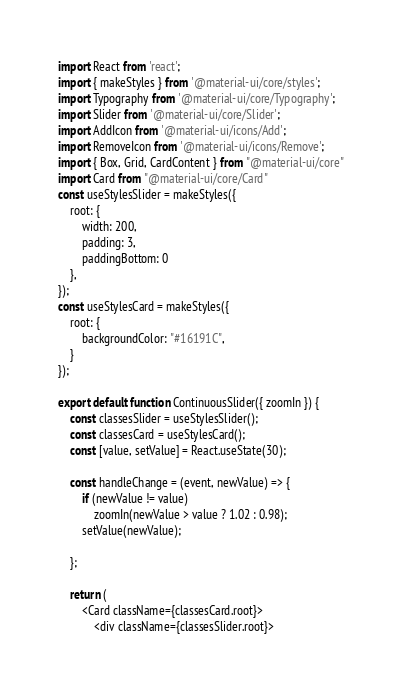<code> <loc_0><loc_0><loc_500><loc_500><_JavaScript_>import React from 'react';
import { makeStyles } from '@material-ui/core/styles';
import Typography from '@material-ui/core/Typography';
import Slider from '@material-ui/core/Slider';
import AddIcon from '@material-ui/icons/Add';
import RemoveIcon from '@material-ui/icons/Remove';
import { Box, Grid, CardContent } from "@material-ui/core"
import Card from "@material-ui/core/Card"
const useStylesSlider = makeStyles({
    root: {
        width: 200,
        padding: 3,
        paddingBottom: 0
    },
});
const useStylesCard = makeStyles({
    root: {
        backgroundColor: "#16191C",
    }
});

export default function ContinuousSlider({ zoomIn }) {
    const classesSlider = useStylesSlider();
    const classesCard = useStylesCard();
    const [value, setValue] = React.useState(30);

    const handleChange = (event, newValue) => {
        if (newValue != value)
            zoomIn(newValue > value ? 1.02 : 0.98);
        setValue(newValue);

    };

    return (
        <Card className={classesCard.root}>
            <div className={classesSlider.root}></code> 